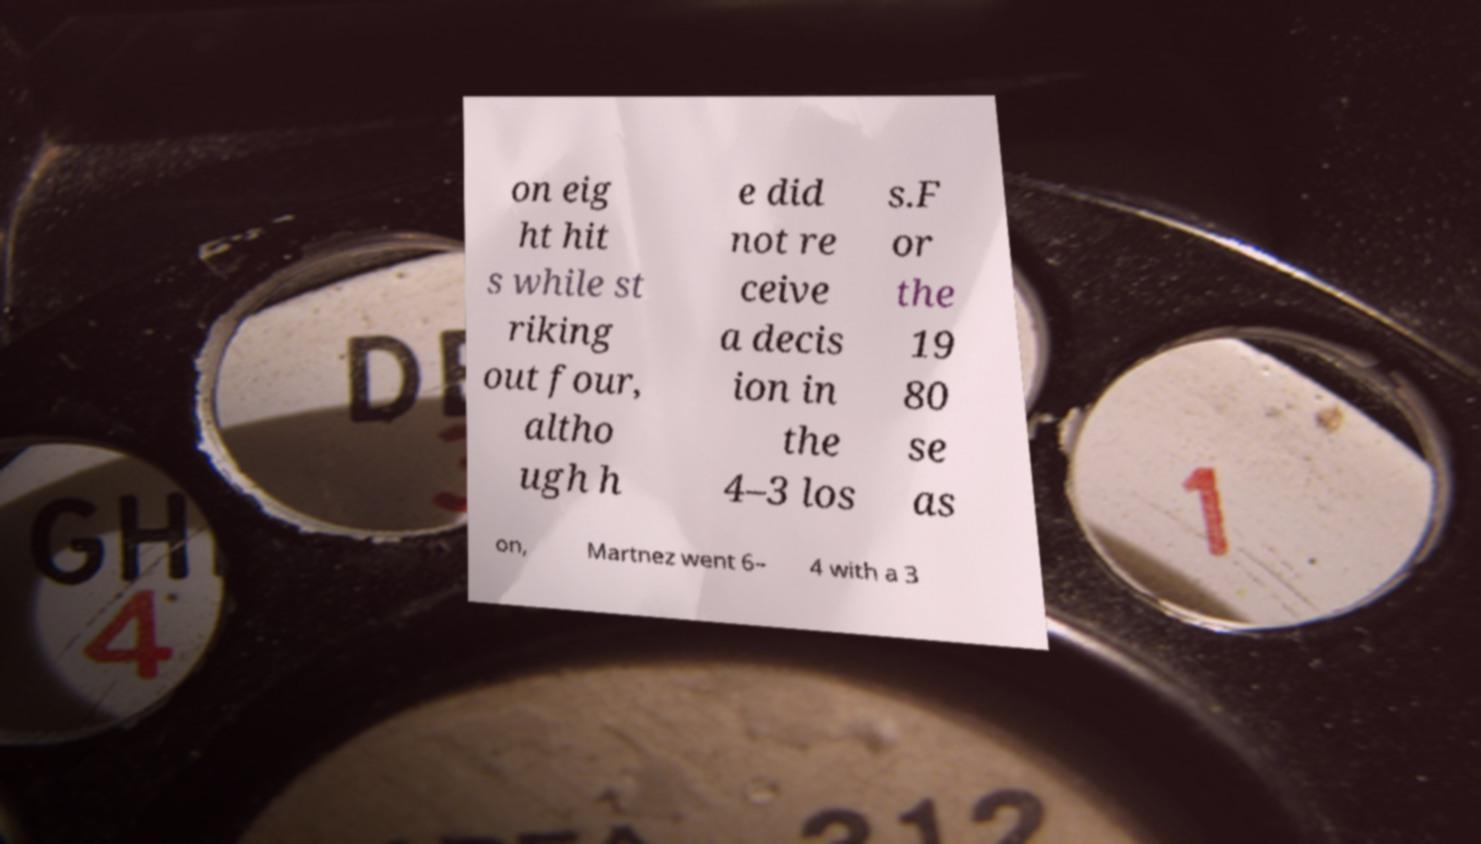Please read and relay the text visible in this image. What does it say? on eig ht hit s while st riking out four, altho ugh h e did not re ceive a decis ion in the 4–3 los s.F or the 19 80 se as on, Martnez went 6– 4 with a 3 